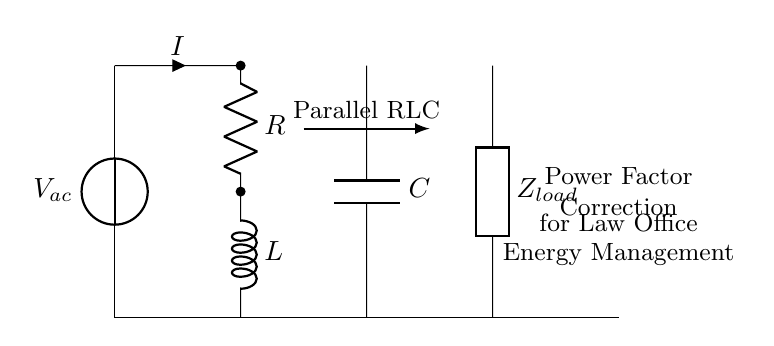What is the main voltage source in this circuit? The main voltage source in the circuit is labeled \(V_{ac}\), indicating an alternating current source that powers the parallel RLC circuit.
Answer: V_ac Which components are in parallel in this circuit? The components in parallel are the resistor \(R\), inductor \(L\), and capacitor \(C\), connected together at one node while sharing the same voltage level across them.
Answer: R, L, C What type of circuit is depicted here? The circuit depicted is a parallel RLC circuit, characterized by the arrangement of resistor, inductor, and capacitor connected in parallel to manage power factor correction.
Answer: Parallel RLC circuit What does the arrow direction indicate regarding current flow? The arrow direction for the current \(I\) indicates that current flows from the voltage source \(V_{ac}\) towards the parallel RLC components and load \(Z_{load}\).
Answer: Current flow Why is power factor correction used in this circuit? Power factor correction is used to improve the efficiency of the electrical system by reducing phase difference between the voltage and current; this is usually necessary in commercial settings like law offices to lower energy costs.
Answer: Efficiency improvement How does the load affect the circuit's performance? The load \(Z_{load}\) represents the total impedance that affects how much current flows through the circuit, influencing the overall performance and efficiency of power usage in the law office.
Answer: Total impedance What is the purpose of including the parallel RLC arrangement for energy management? The parallel RLC arrangement is included for energy management to minimize reactive power, enhance voltage stability, and improve the overall power factor, leading to lower energy costs and better utilization of power.
Answer: Minimize reactive power 